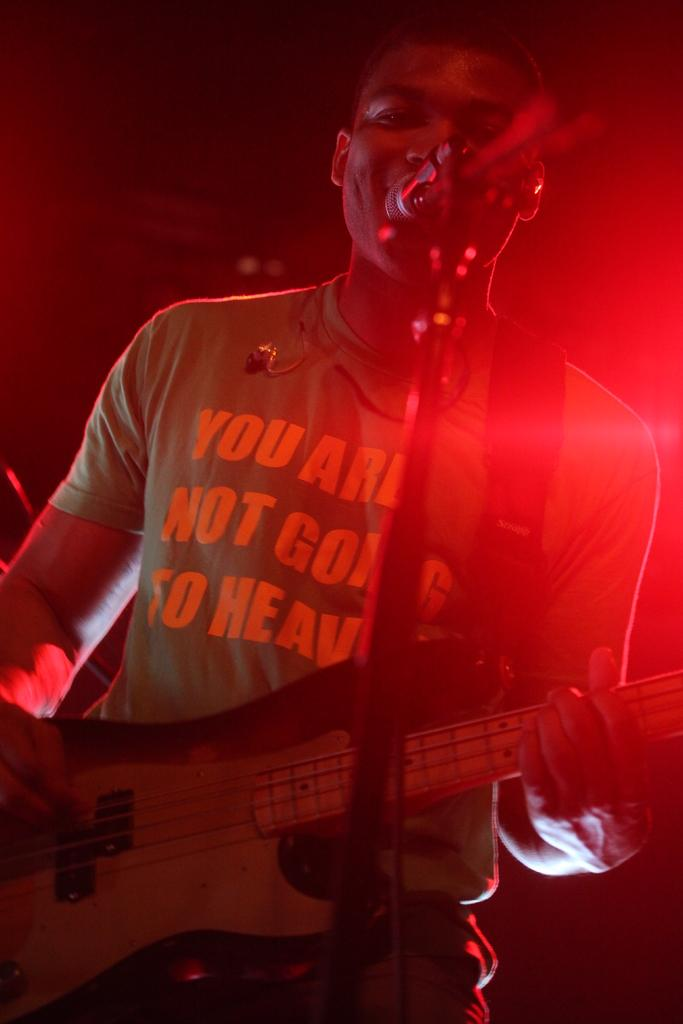What is the person in the image holding? The person is holding a musical instrument. What object is present for amplifying sound? There is a microphone with a pole in the image. What color is the light visible in the image? The light visible in the image is red. How would you describe the lighting conditions in the background of the image? The background of the image is dark. What type of disease is affecting the crops on the farm in the image? There is no farm or crops present in the image, so it is not possible to determine if there is any disease affecting them. 